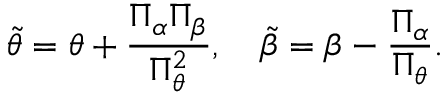Convert formula to latex. <formula><loc_0><loc_0><loc_500><loc_500>\tilde { \theta } = \theta + { \frac { \Pi _ { \alpha } \Pi _ { \beta } } { \Pi _ { \theta } ^ { 2 } } } , \tilde { \beta } = \beta - { \frac { \Pi _ { \alpha } } { \Pi _ { \theta } } } .</formula> 